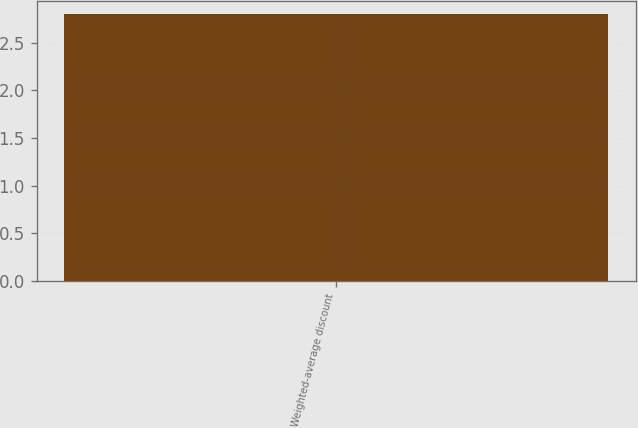<chart> <loc_0><loc_0><loc_500><loc_500><bar_chart><fcel>Weighted-average discount<nl><fcel>2.8<nl></chart> 